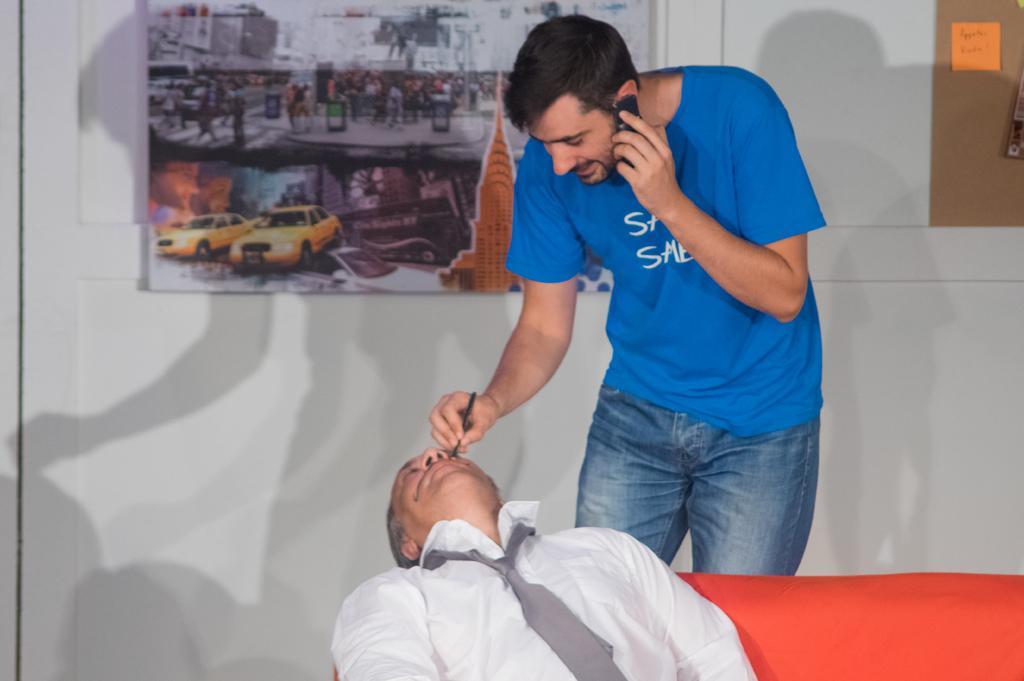How would you summarize this image in a sentence or two? At the bottom of the image there is a person sitting on a red color couch wearing white color shirt. Behind him there is a person standing and talking on phone. In the background of the image there is wall. There are posters on the wall. 